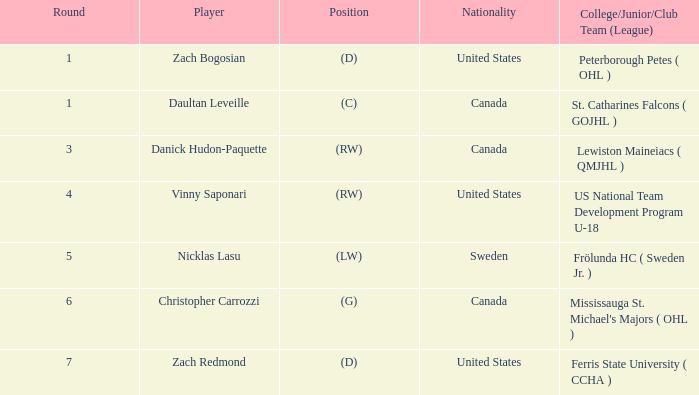What is the Player in Round 5? Nicklas Lasu. 